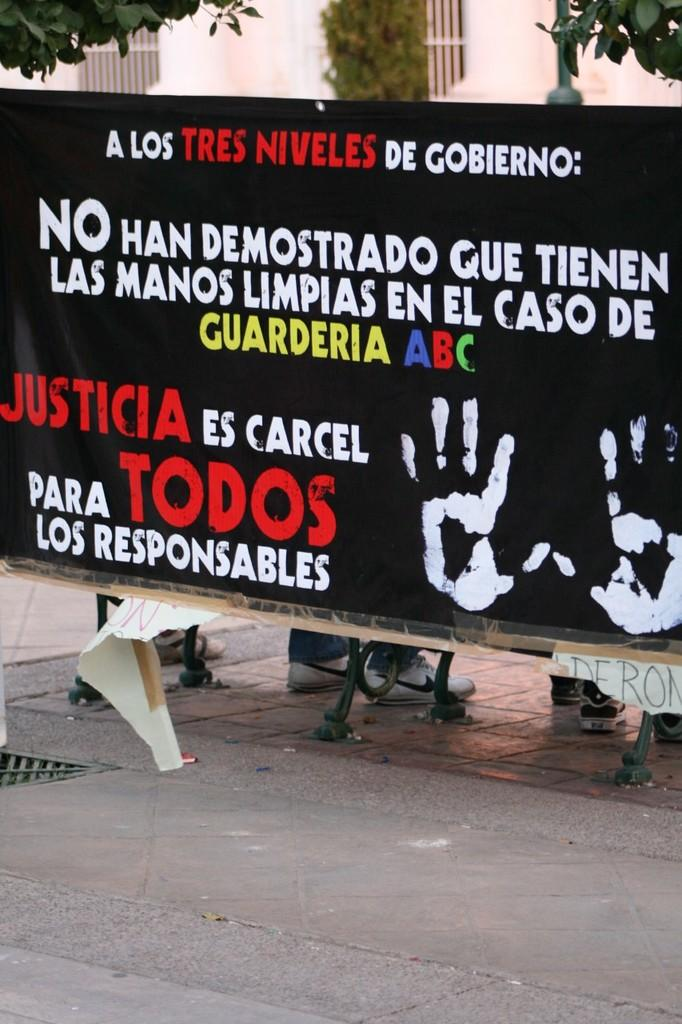What is written or displayed on the banner in the image? There is a banner with text in the image, but the specific text is not mentioned in the facts. What part of people can be seen in the image? The legs of people are visible in the image. What type of structure can be seen in the image? There are metal poles in the image. What type of vegetation is present in the image? There are plants in the image. What type of barrier can be seen in the image? There is a fence in the image. What type of vertical surface can be seen in the image? There is a wall in the image. What type of notebook is being used by the dinosaurs in the image? There are no dinosaurs present in the image, so there is no notebook being used by them. What part of the head can be seen in the image? There is no head visible in the image; only legs, metal poles, plants, a fence, and a wall are mentioned. 